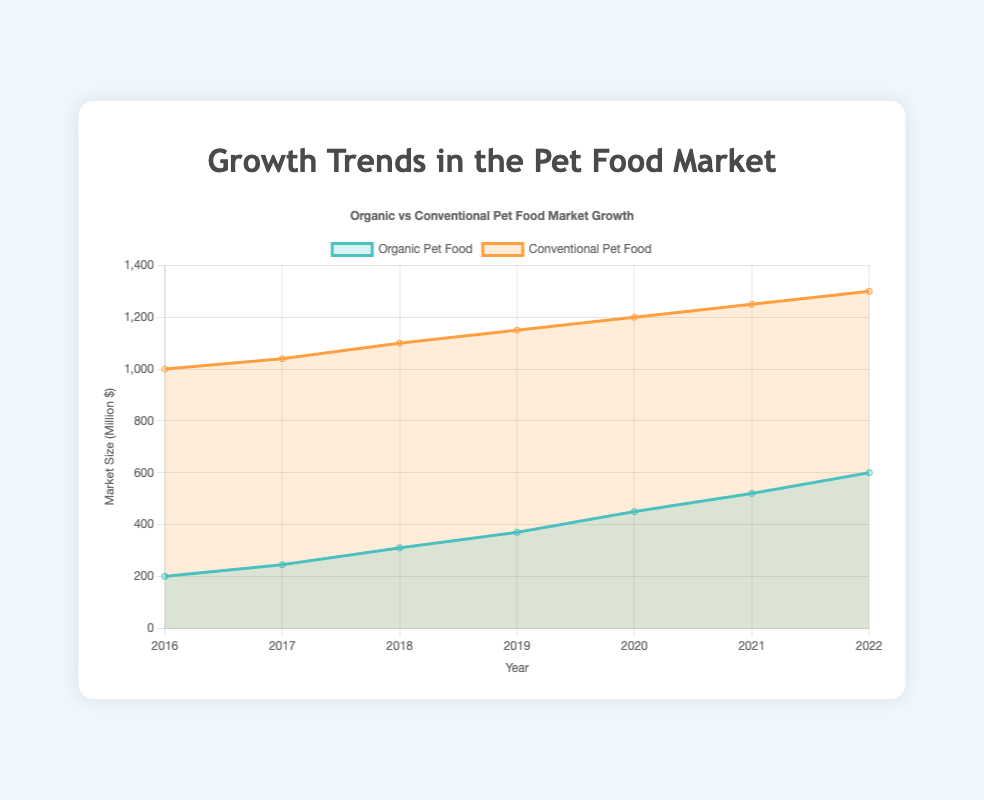What is the title of the figure? Look at the title text located at the top of the figure.
Answer: Growth Trends in the Pet Food Market How many years are represented in the dataset? Count the number of ticks on the x-axis that represent years.
Answer: 7 Which type of pet food had a higher market size in 2018? Compare the values of Organic and Conventional Pet Food in 2018.
Answer: Conventional Pet Food What was the market size for Organic Pet Food in 2020? Locate the point for Organic Pet Food on the y-axis corresponding to the year 2020.
Answer: 450 million $ Calculate the total growth in market size for Conventional Pet Food from 2016 to 2022. Subtract the 2016 value from the 2022 value for Conventional Pet Food: 1300 - 1000 = 300.
Answer: 300 million $ By how much did Organic Pet Food grow between 2017 and 2019? Subtract the 2017 value from the 2019 value for Organic Pet Food: 370 - 245 = 125.
Answer: 125 million $ Was the growth rate higher for Organic or Conventional Pet Food between 2020 and 2021? Compare the differences: Organic (520-450=70) and Conventional (1250-1200=50). Organic has a higher growth.
Answer: Organic Pet Food Which year did Organic Pet Food surpass 500 million dollars? Find the first year on the x-axis where Organic Pet Food's value exceeds 500.
Answer: 2021 What is the trend for both types of pet food from 2016 to 2022? Observe the changes in the values from the start point in 2016 to the endpoint in 2022 for both Organic and Conventional Pet Food.
Answer: Both increasing Who has the larger share of the pet food market in 2022? Compare the values of Organic and Conventional Pet Food in 2022.
Answer: Conventional Pet Food 